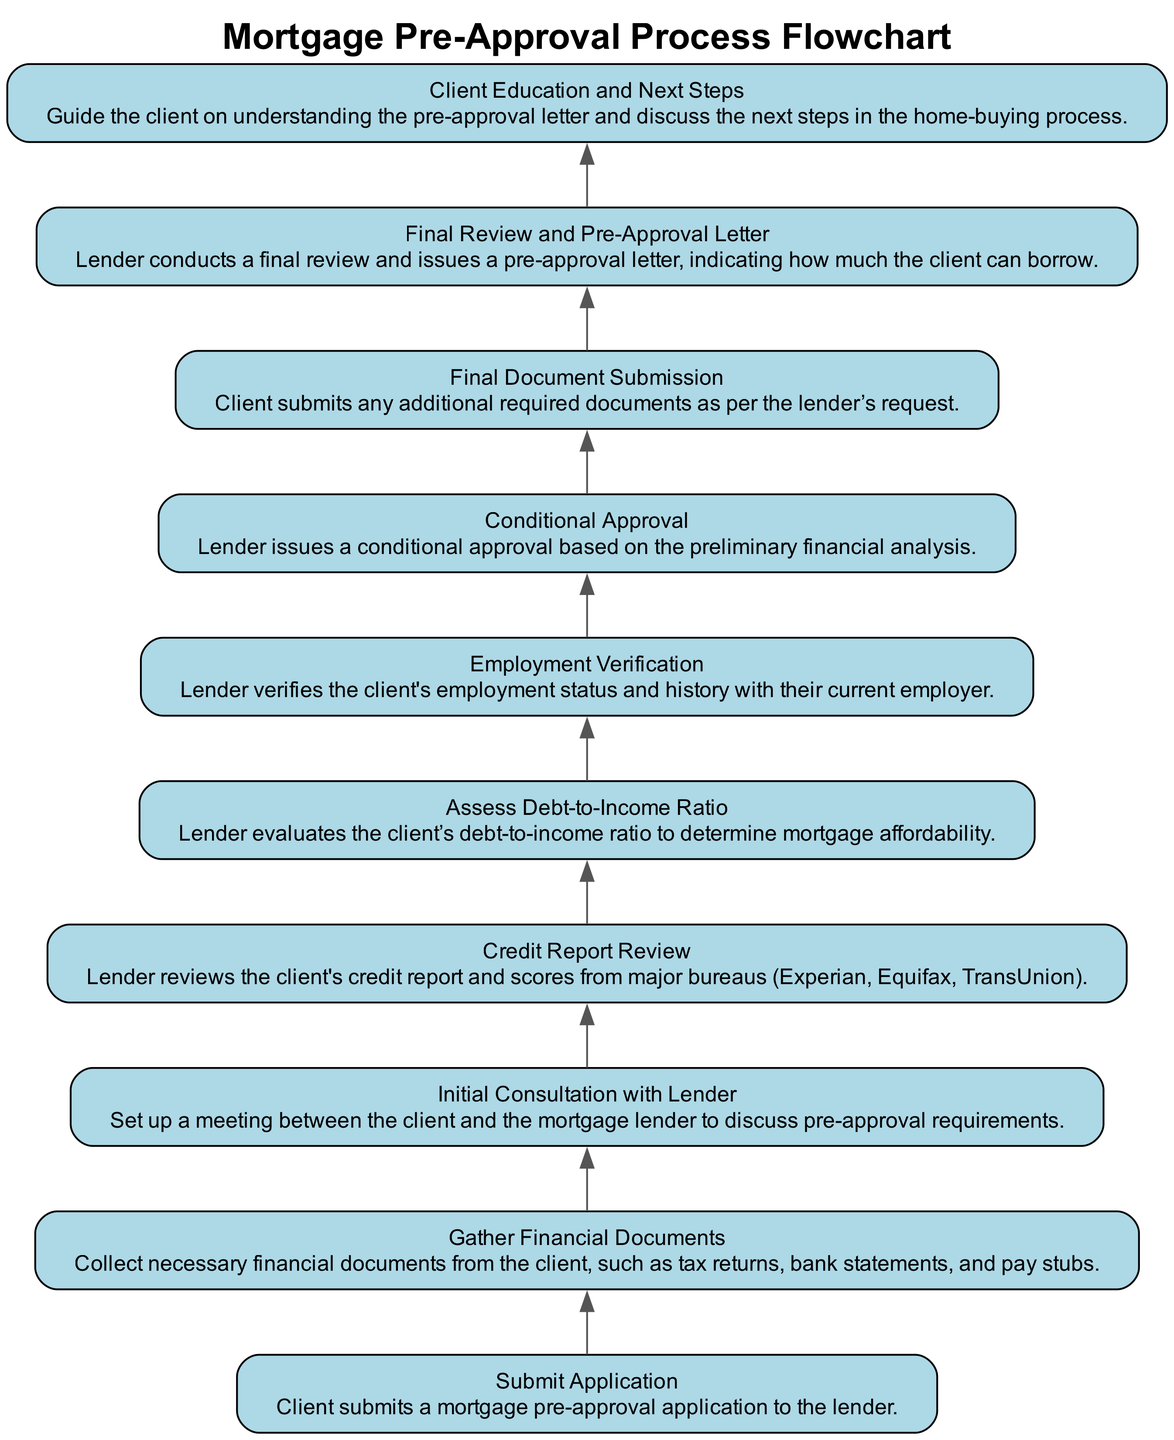What is the first step of the Pre-Approval Process? The diagram clearly indicates that the first step is "Submit Application," which is the starting point of the entire process flow.
Answer: Submit Application How many total steps are in the Pre-Approval Process? By counting the individual steps listed in the diagram, there are a total of ten distinct steps in the Pre-Approval Process.
Answer: 10 What is the last step in the flowchart? The flowchart concludes with "Client Education and Next Steps," which provides guidance to the client about the pre-approval letter and subsequent actions.
Answer: Client Education and Next Steps Which step comes after "Gather Financial Documents"? In the flow, the step immediately following "Gather Financial Documents" is "Initial Consultation with Lender," indicating a sequence in the process where the gathered documents are discussed with the lender.
Answer: Initial Consultation with Lender What type of approval is issued after the "Credit Report Review"? The diagram shows that after "Credit Report Review," the next step is "Assess Debt-to-Income Ratio," leading to a "Conditional Approval" based on an analysis of financial factors, indicating a preliminary acceptance stage.
Answer: Conditional Approval What document is submitted in the "Final Document Submission" step? The diagram specifies that this step requires the client to submit "any additional required documents as per the lender’s request," indicating that this submission entails documents that may vary based on prior reviews.
Answer: Additional required documents Which step includes the verification of the client's employment? The step "Employment Verification" focuses specifically on the verification of the client's employment status and history, as recognized in the sequence of the mortgage pre-approval process.
Answer: Employment Verification What role does the "Initial Consultation with Lender" play in the process? The "Initial Consultation with Lender" is vital as it allows the client to understand pre-approval requirements and clarify any uncertainties prior to submitting financial documents.
Answer: Discuss pre-approval requirements How does the lender assess mortgage affordability? The lender assesses mortgage affordability primarily through the evaluation of the client’s "Debt-to-Income Ratio," which is a critical financial metric in this process.
Answer: Debt-to-Income Ratio 